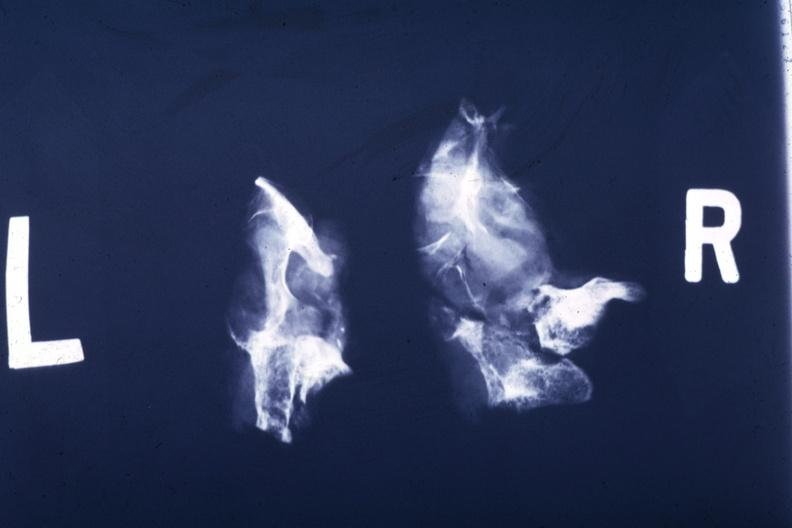what is present?
Answer the question using a single word or phrase. Pituitary 